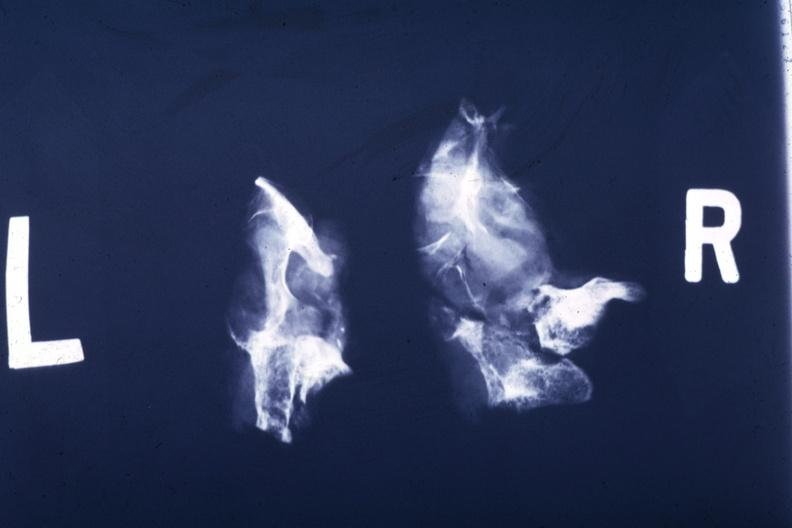what is present?
Answer the question using a single word or phrase. Pituitary 